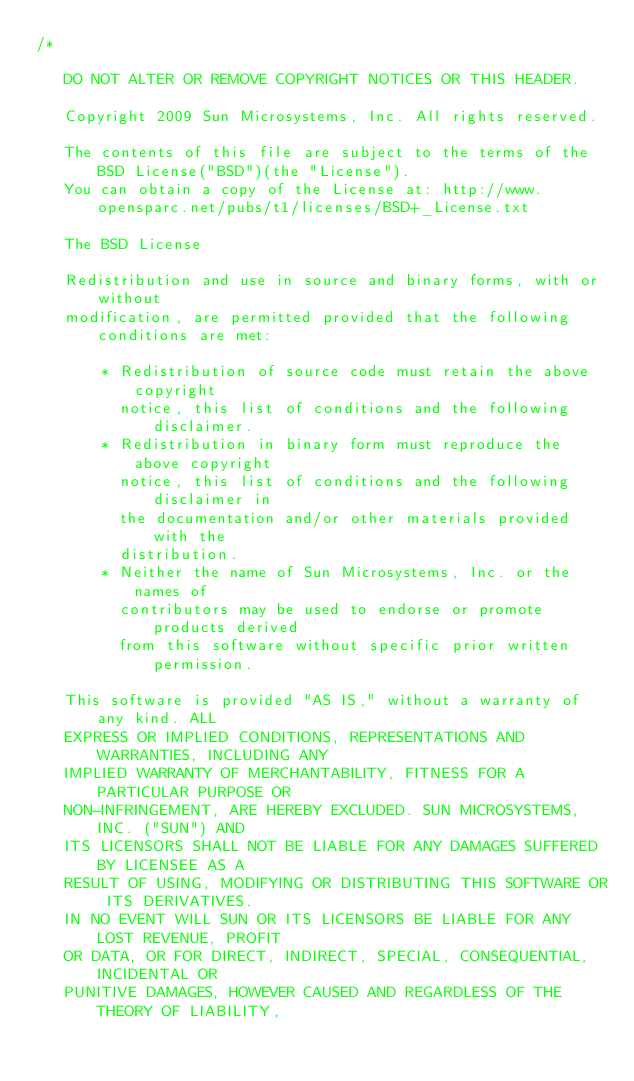Convert code to text. <code><loc_0><loc_0><loc_500><loc_500><_C_>/*

   DO NOT ALTER OR REMOVE COPYRIGHT NOTICES OR THIS HEADER.

   Copyright 2009 Sun Microsystems, Inc. All rights reserved.

   The contents of this file are subject to the terms of the BSD License("BSD")(the "License"). 
   You can obtain a copy of the License at: http://www.opensparc.net/pubs/t1/licenses/BSD+_License.txt

   The BSD License

   Redistribution and use in source and binary forms, with or without 
   modification, are permitted provided that the following conditions are met:

       * Redistribution of source code must retain the above copyright 
         notice, this list of conditions and the following disclaimer.
       * Redistribution in binary form must reproduce the above copyright 
         notice, this list of conditions and the following disclaimer in 
         the documentation and/or other materials provided with the 
         distribution.
       * Neither the name of Sun Microsystems, Inc. or the names of 
         contributors may be used to endorse or promote products derived 
         from this software without specific prior written permission.

   This software is provided "AS IS," without a warranty of any kind. ALL 
   EXPRESS OR IMPLIED CONDITIONS, REPRESENTATIONS AND WARRANTIES, INCLUDING ANY 
   IMPLIED WARRANTY OF MERCHANTABILITY, FITNESS FOR A PARTICULAR PURPOSE OR 
   NON-INFRINGEMENT, ARE HEREBY EXCLUDED. SUN MICROSYSTEMS, INC. ("SUN") AND 
   ITS LICENSORS SHALL NOT BE LIABLE FOR ANY DAMAGES SUFFERED BY LICENSEE AS A 
   RESULT OF USING, MODIFYING OR DISTRIBUTING THIS SOFTWARE OR ITS DERIVATIVES. 
   IN NO EVENT WILL SUN OR ITS LICENSORS BE LIABLE FOR ANY LOST REVENUE, PROFIT 
   OR DATA, OR FOR DIRECT, INDIRECT, SPECIAL, CONSEQUENTIAL, INCIDENTAL OR 
   PUNITIVE DAMAGES, HOWEVER CAUSED AND REGARDLESS OF THE THEORY OF LIABILITY, </code> 